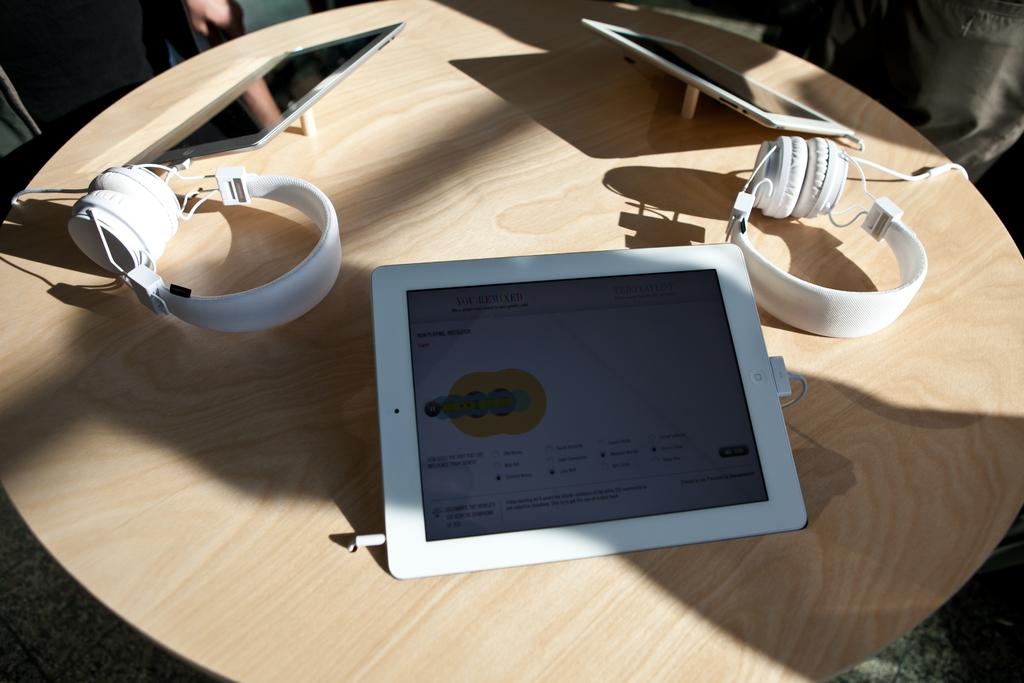What piece of furniture is present in the image? There is a table in the image. What electronic device is on the table? There is an iPad on the table. What accessory is also on the table? There are headphones on the table. What type of skin is visible on the iPad in the image? There is no skin visible on the iPad in the image; it is an electronic device with a screen and casing. 